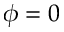Convert formula to latex. <formula><loc_0><loc_0><loc_500><loc_500>\phi = 0</formula> 